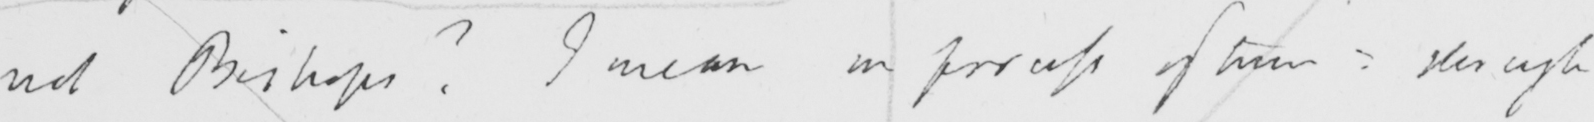Can you tell me what this handwritten text says? not Bishops ?  I mean in process of time :  though 